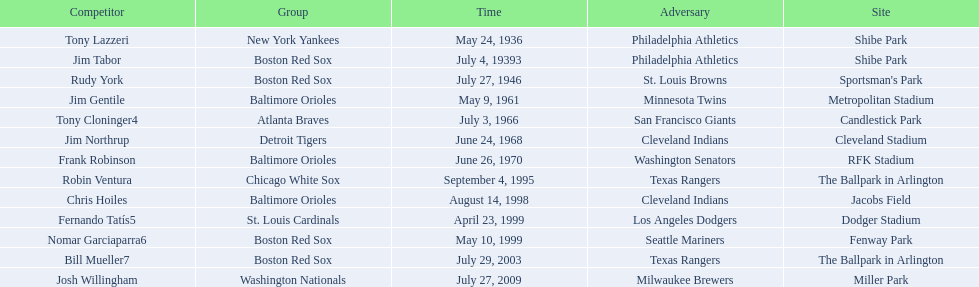Which teams played between the years 1960 and 1970? Baltimore Orioles, Atlanta Braves, Detroit Tigers, Baltimore Orioles. Of these teams that played, which ones played against the cleveland indians? Detroit Tigers. On what day did these two teams play? June 24, 1968. 